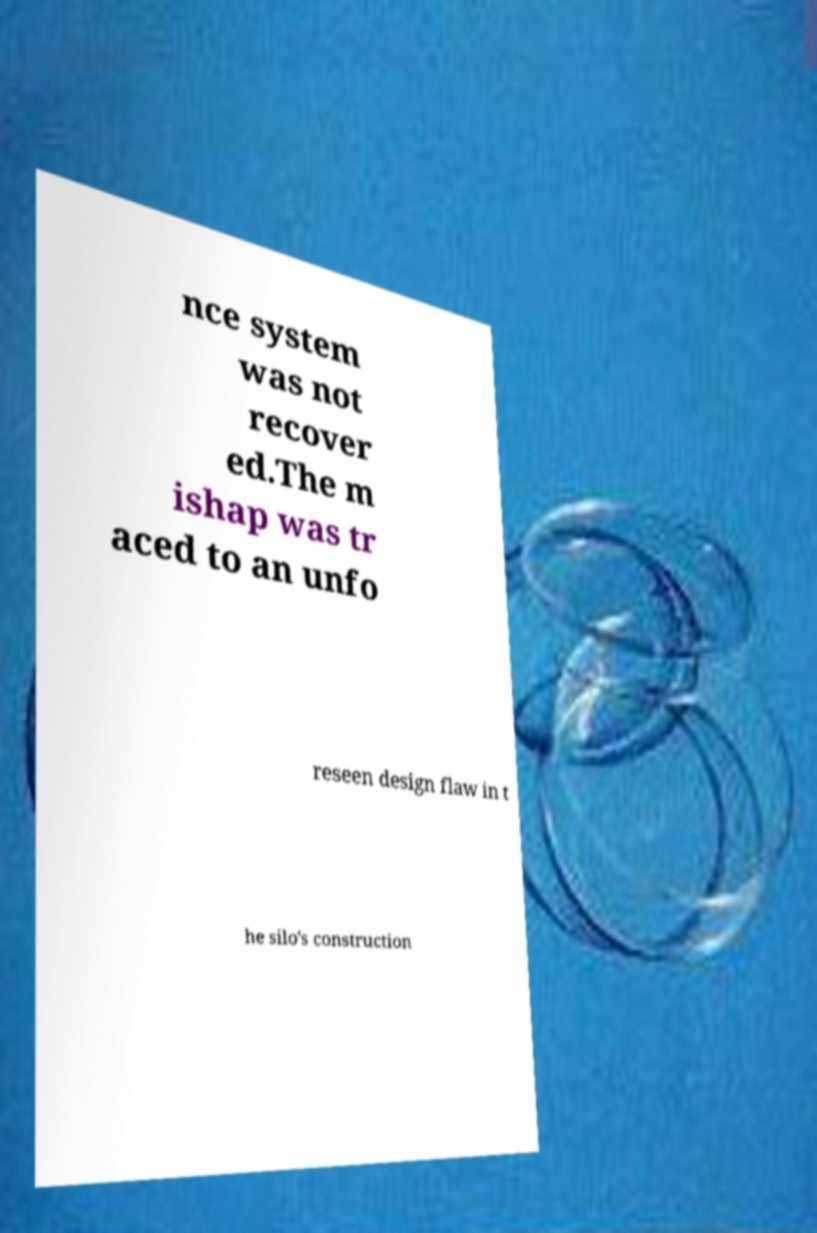For documentation purposes, I need the text within this image transcribed. Could you provide that? nce system was not recover ed.The m ishap was tr aced to an unfo reseen design flaw in t he silo's construction 